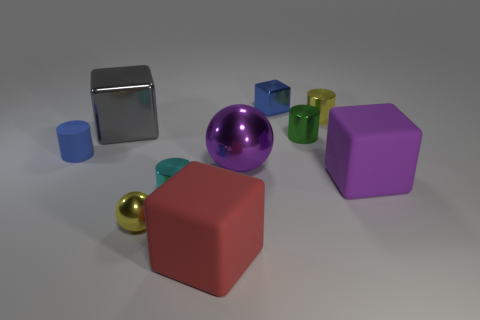What size is the block that is both right of the purple metal sphere and to the left of the big purple matte cube? The block that is situated to the right of the purple metal sphere and to the left of the large purple matte cube is small in size. It's a small blue cube, standing out due to its size in contrast with the larger objects nearby. 